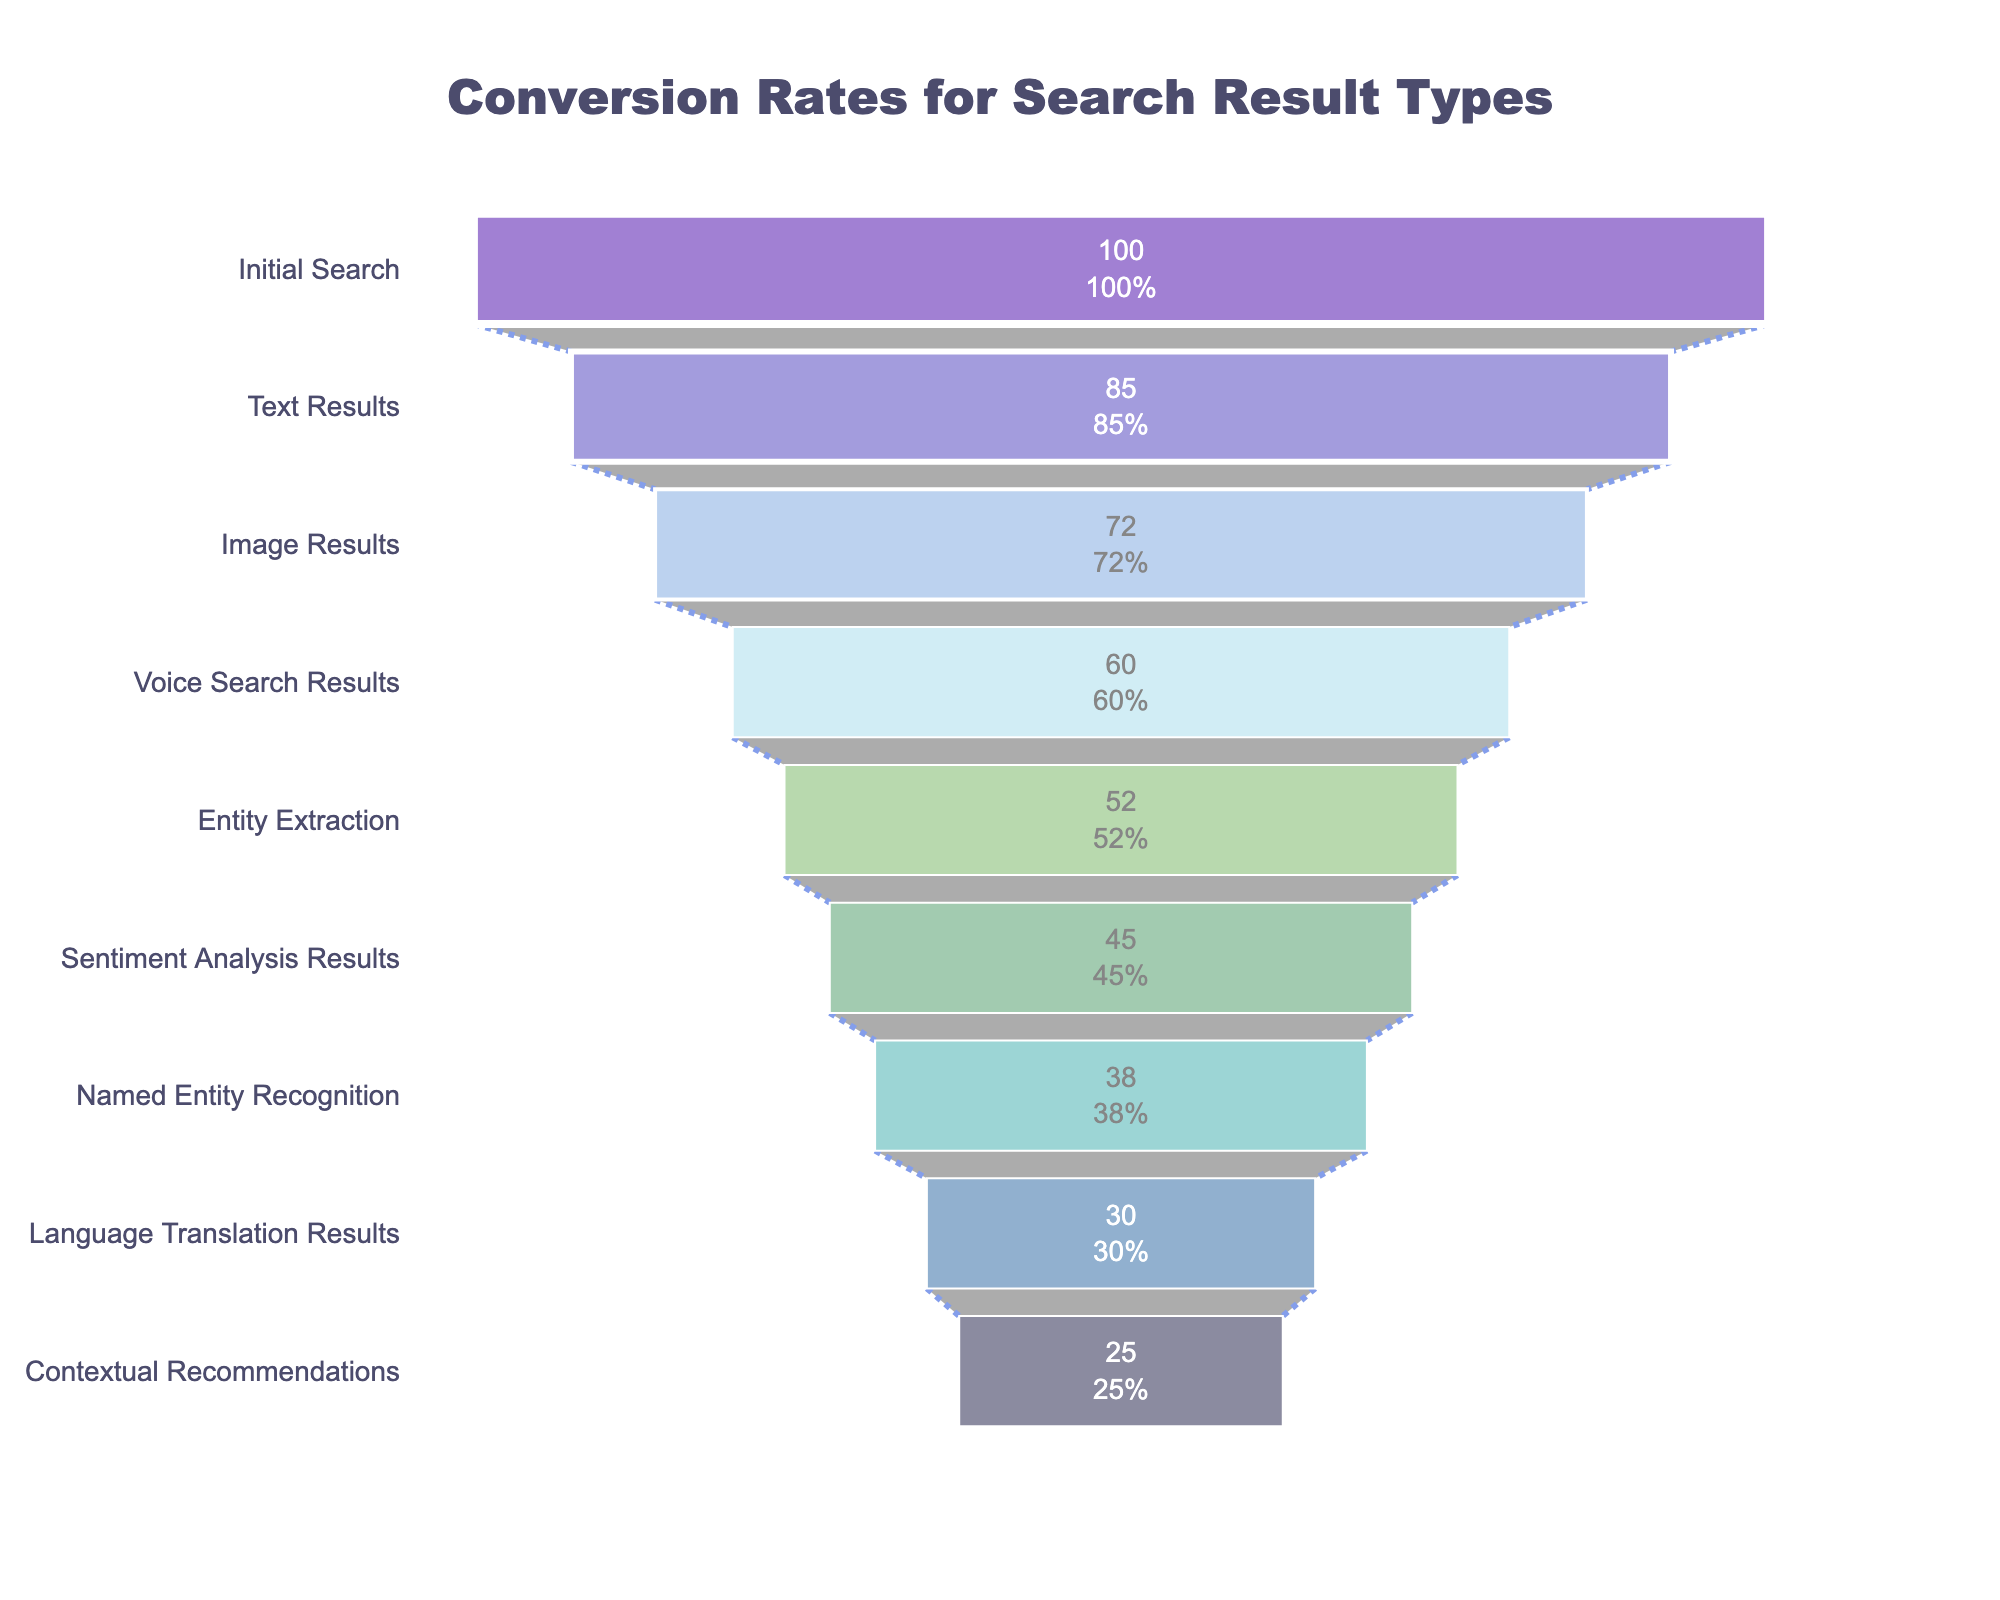What is the title of the funnel chart? The title of the funnel chart is typically displayed at the top of the figure.
Answer: Conversion Rates for Search Result Types How many stages are there in the funnel chart? Count each unique stage listed on the y-axis.
Answer: 9 Which stage has the lowest conversion rate? Look for the stage at the bottom of the funnel with the lowest x-axis value.
Answer: Contextual Recommendations What is the percentage drop from "Initial Search" to "Named Entity Recognition"? Subtract the conversion rate of "Named Entity Recognition" from "Initial Search" (100% - 38%).
Answer: 62% Which stage experienced the smallest drop in conversion rate from its preceding stage? Calculate the difference in conversion rates between each consecutive stage and identify the smallest difference. The smallest difference is between "Entity Extraction" and "Sentiment Analysis Results" (52% - 45% = 7%).
Answer: Entity Extraction to Sentiment Analysis Results What is the conversion rate at "Image Results"? Find the conversion rate corresponding to the "Image Results" stage.
Answer: 72% By how much does the conversion rate decrease from "Voice Search Results" to "Language Translation Results"? Subtract the conversion rate at "Language Translation Results" from "Voice Search Results" (60% - 30%).
Answer: 30% Which two stages have conversion rates that are closest to each other? Find the pair of consecutive stages with the smallest difference in their conversion rates. The smallest difference is between "Entity Extraction" and "Sentiment Analysis Results" (52% - 45% = 7%).
Answer: Entity Extraction and Sentiment Analysis Results What is the average conversion rate of all stages? Sum all the conversion rates and divide by the number of stages. (100% + 85% + 72% + 60% + 52% + 45% + 38% + 30% + 25%) / 9
Answer: 56.33% Which stage comes directly after "Text Results"? Identify the next stage listed below "Text Results" on the y-axis.
Answer: Image Results 